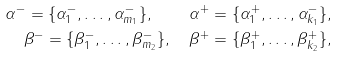<formula> <loc_0><loc_0><loc_500><loc_500>\alpha ^ { - } = \{ \alpha ^ { - } _ { 1 } , \dots , \alpha ^ { - } _ { m _ { 1 } } \} , \quad \alpha ^ { + } = \{ \alpha ^ { + } _ { 1 } , \dots , \alpha ^ { - } _ { k _ { 1 } } \} , \\ \beta ^ { - } = \{ \beta _ { 1 } ^ { - } , \dots , \beta ^ { - } _ { m _ { 2 } } \} , \quad \beta ^ { + } = \{ \beta _ { 1 } ^ { + } , \dots , \beta ^ { + } _ { k _ { 2 } } \} ,</formula> 